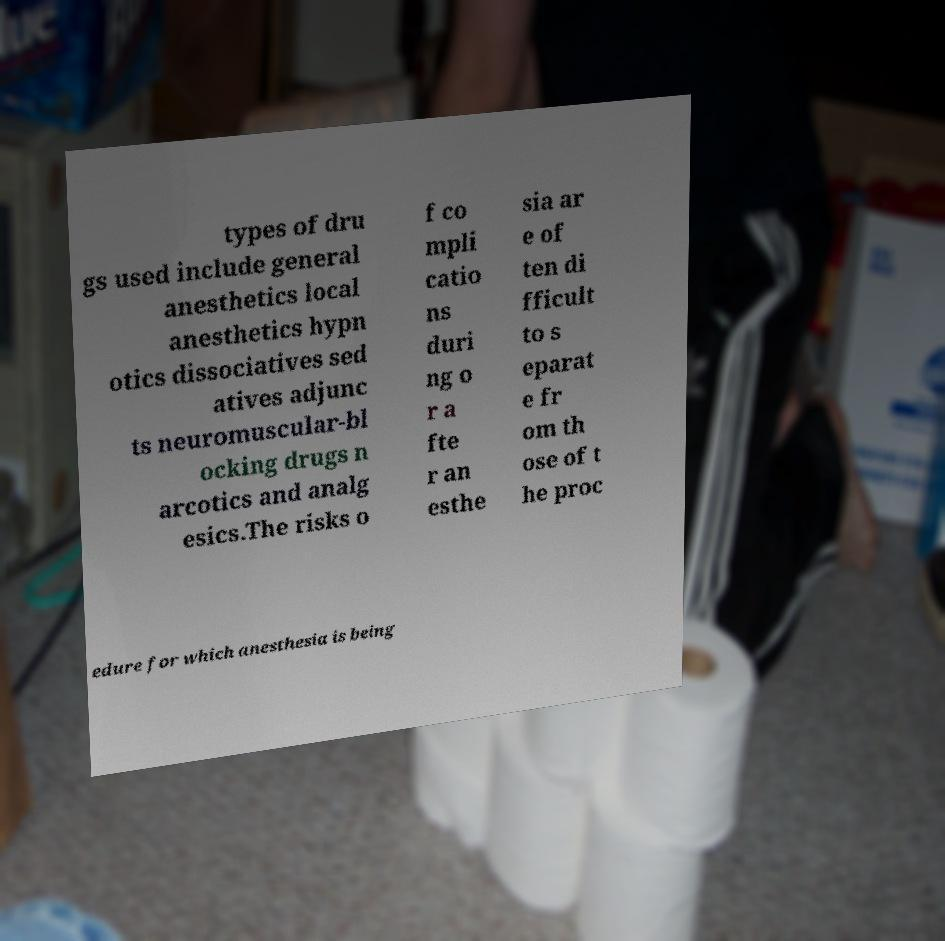For documentation purposes, I need the text within this image transcribed. Could you provide that? types of dru gs used include general anesthetics local anesthetics hypn otics dissociatives sed atives adjunc ts neuromuscular-bl ocking drugs n arcotics and analg esics.The risks o f co mpli catio ns duri ng o r a fte r an esthe sia ar e of ten di fficult to s eparat e fr om th ose of t he proc edure for which anesthesia is being 